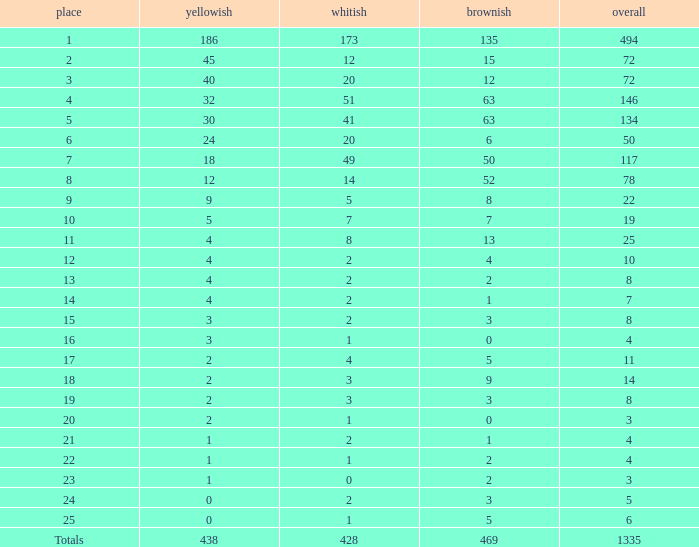What is the number of bronze medals when the total medals were 78 and there were less than 12 golds? None. 